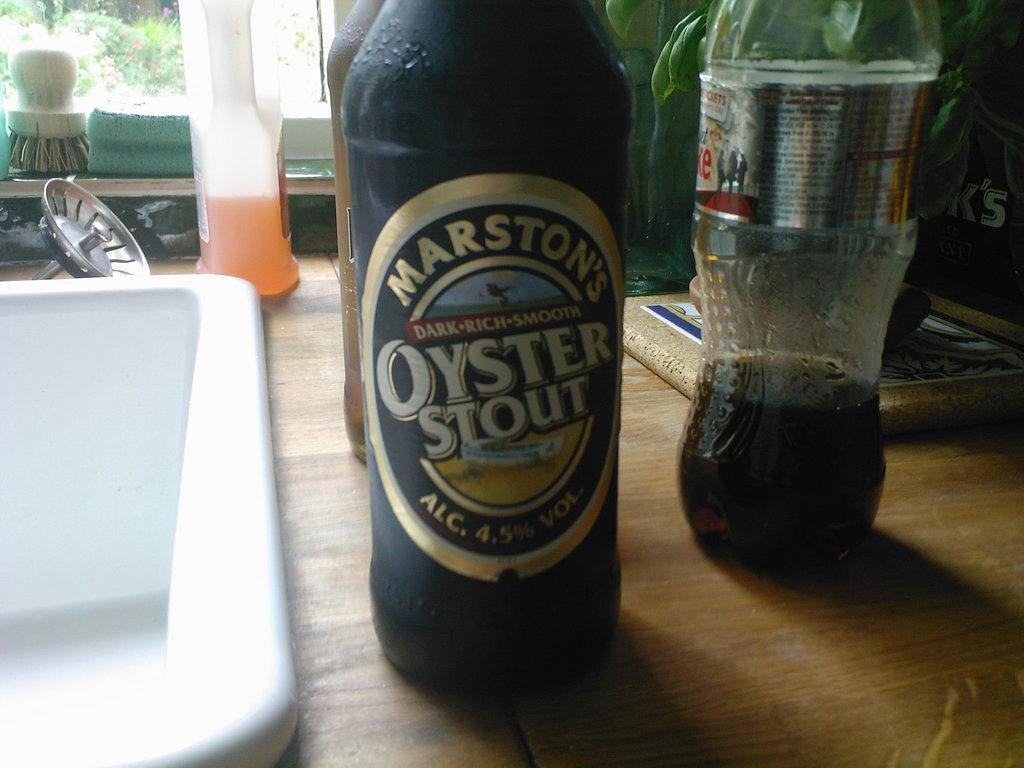Provide a one-sentence caption for the provided image. A Marston's Dark Rich Smooth Oyster Stout beer bottle is next to a kitchen sink. 